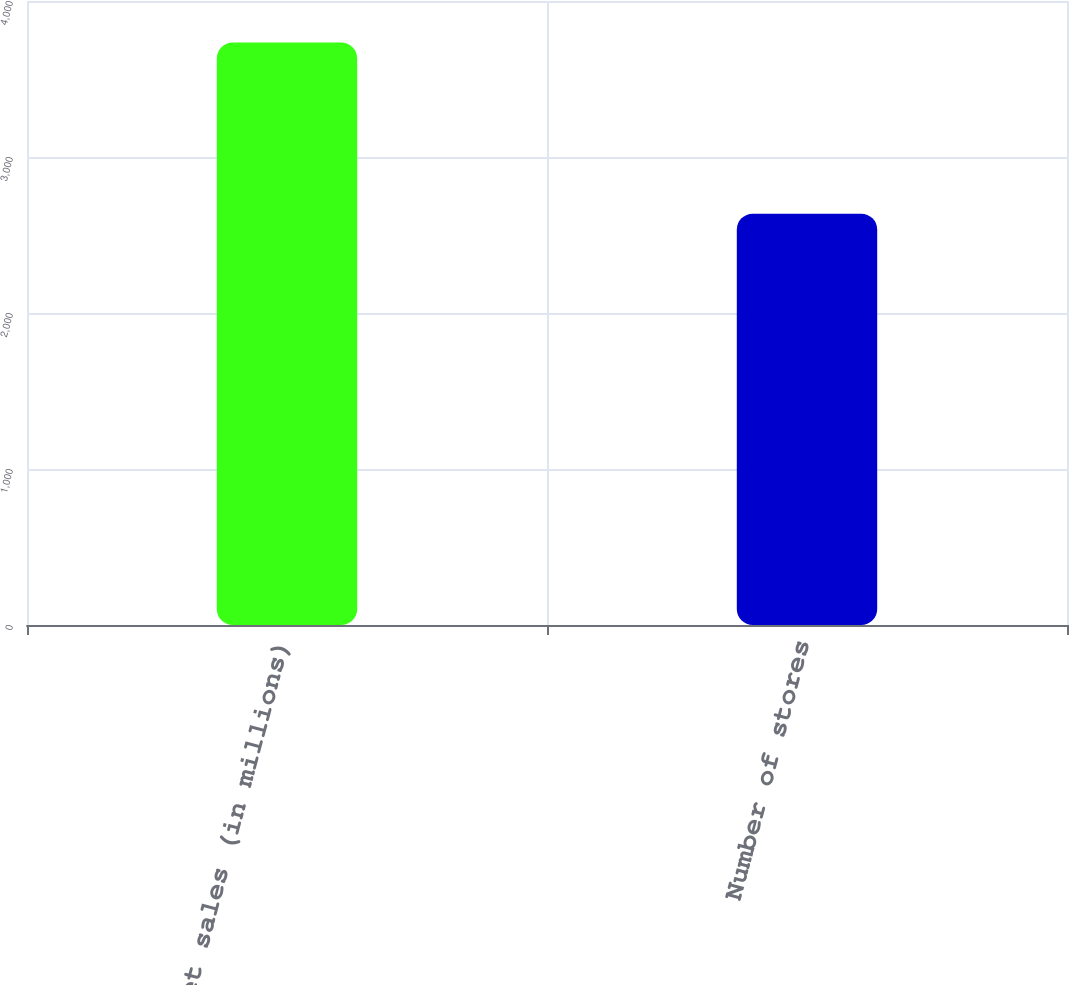Convert chart. <chart><loc_0><loc_0><loc_500><loc_500><bar_chart><fcel>Net sales (in millions)<fcel>Number of stores<nl><fcel>3733.5<fcel>2637<nl></chart> 